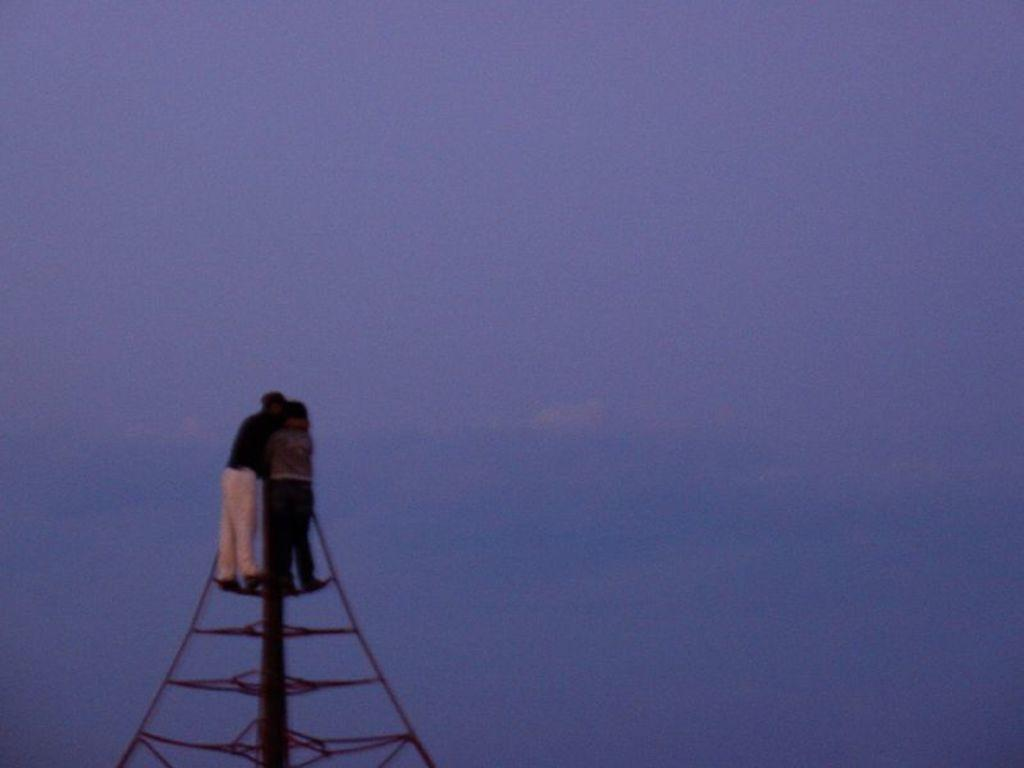What are the two men doing in the image? The two men are standing on a tower in the image. What can be seen in the background of the image? The sky is visible in the background of the image. What is the color of the sky in the image? The color of the sky is blue. How much sugar is being used by the slaves in the image? There are no slaves or sugar present in the image; it features two men standing on a tower. 